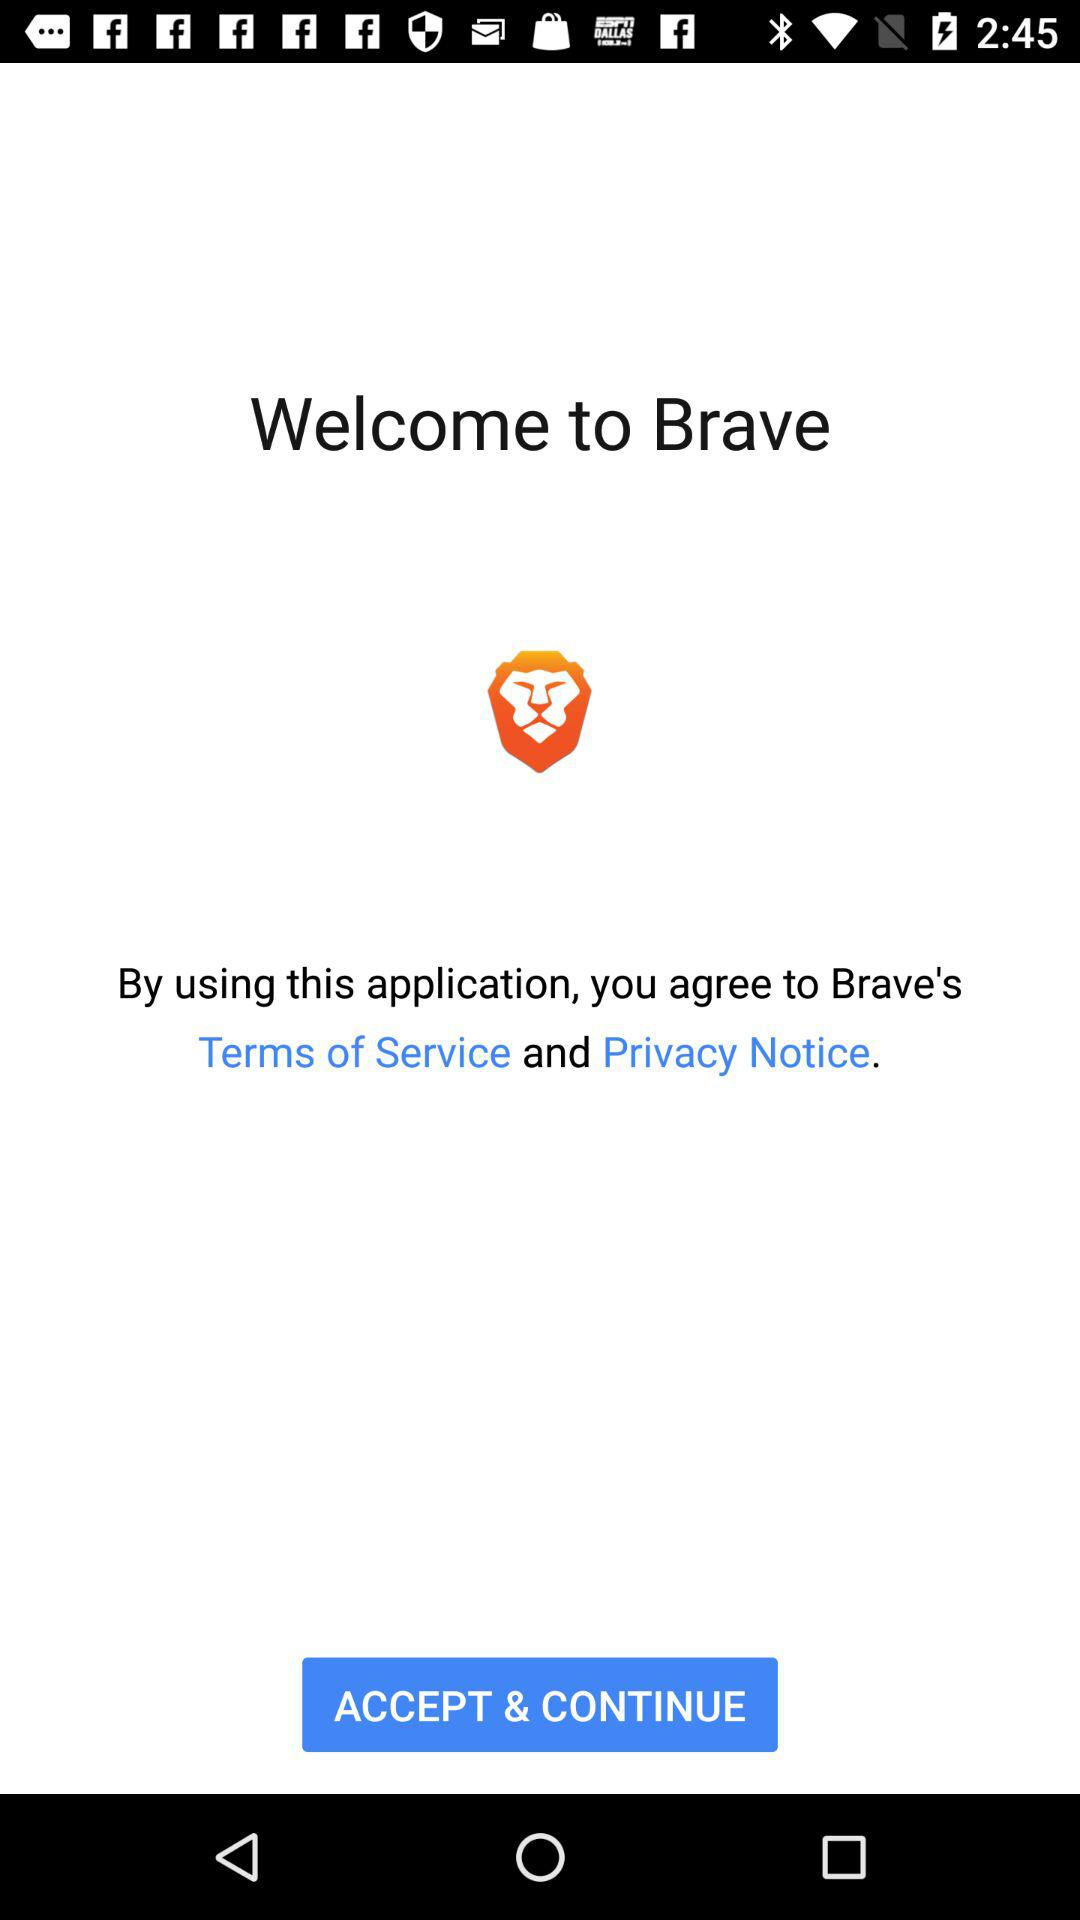What is the application name? The application name is "Brave". 